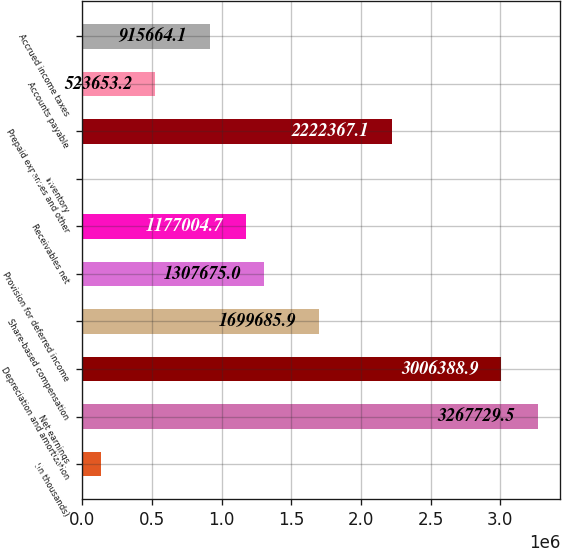<chart> <loc_0><loc_0><loc_500><loc_500><bar_chart><fcel>(In thousands)<fcel>Net earnings<fcel>Depreciation and amortization<fcel>Share-based compensation<fcel>Provision for deferred income<fcel>Receivables net<fcel>Inventory<fcel>Prepaid expenses and other<fcel>Accounts payable<fcel>Accrued income taxes<nl><fcel>131642<fcel>3.26773e+06<fcel>3.00639e+06<fcel>1.69969e+06<fcel>1.30768e+06<fcel>1.177e+06<fcel>972<fcel>2.22237e+06<fcel>523653<fcel>915664<nl></chart> 